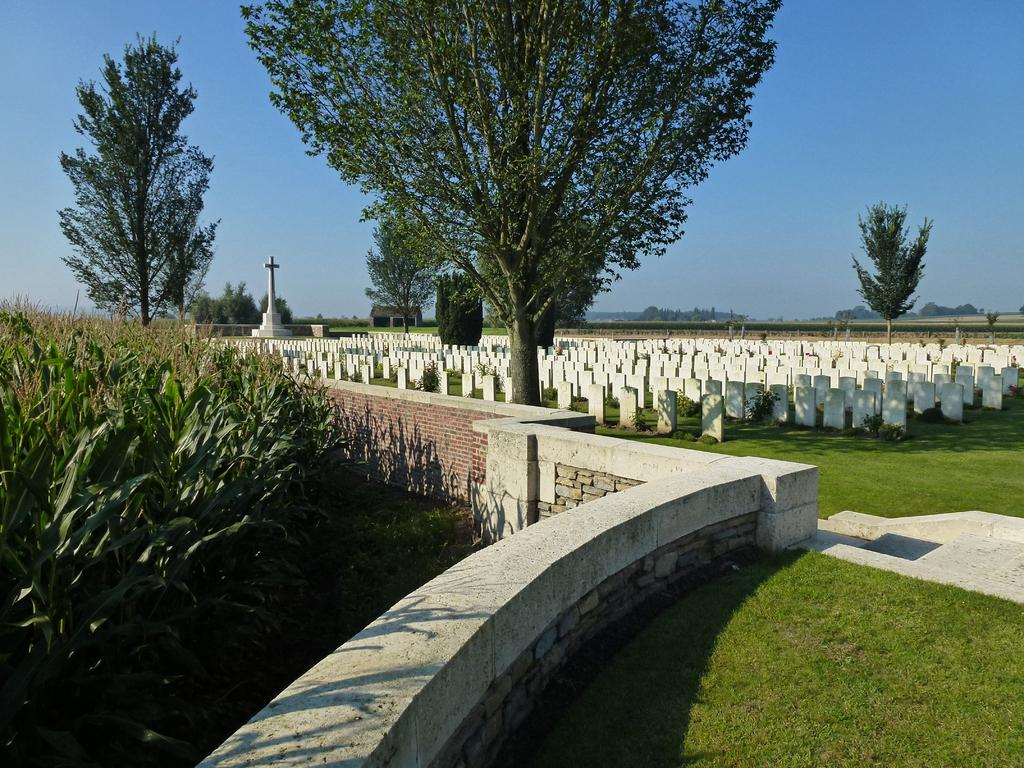Where was the image taken? The image was clicked outside. What can be seen in the middle of the image? There are trees in the middle of the image. What is visible at the top of the image? There is sky visible at the top of the image. What type of vegetation is on the left side of the image? There are bushes on the left side of the image. How many rings are hanging from the branches of the trees in the image? There are no rings visible in the image; it features trees, bushes, and sky. What force is being applied to the bushes on the left side of the image? There is no force being applied to the bushes in the image; they are stationary. 